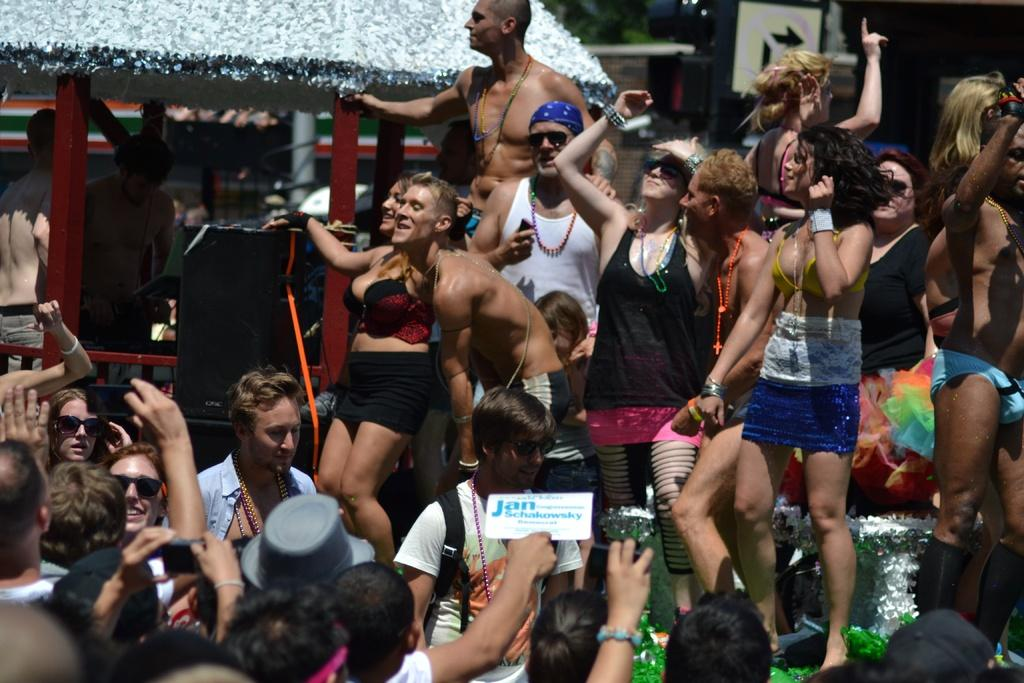How many people are in the image? There is a group of people in the image. What are some of the people doing in the image? Some people are holding objects, dancing, and smiling. What can be seen in the background of the image? There are poles and other objects in the background. What type of locket is hanging from the pole in the image? There is no locket present in the image; only poles and other objects are visible in the background. 